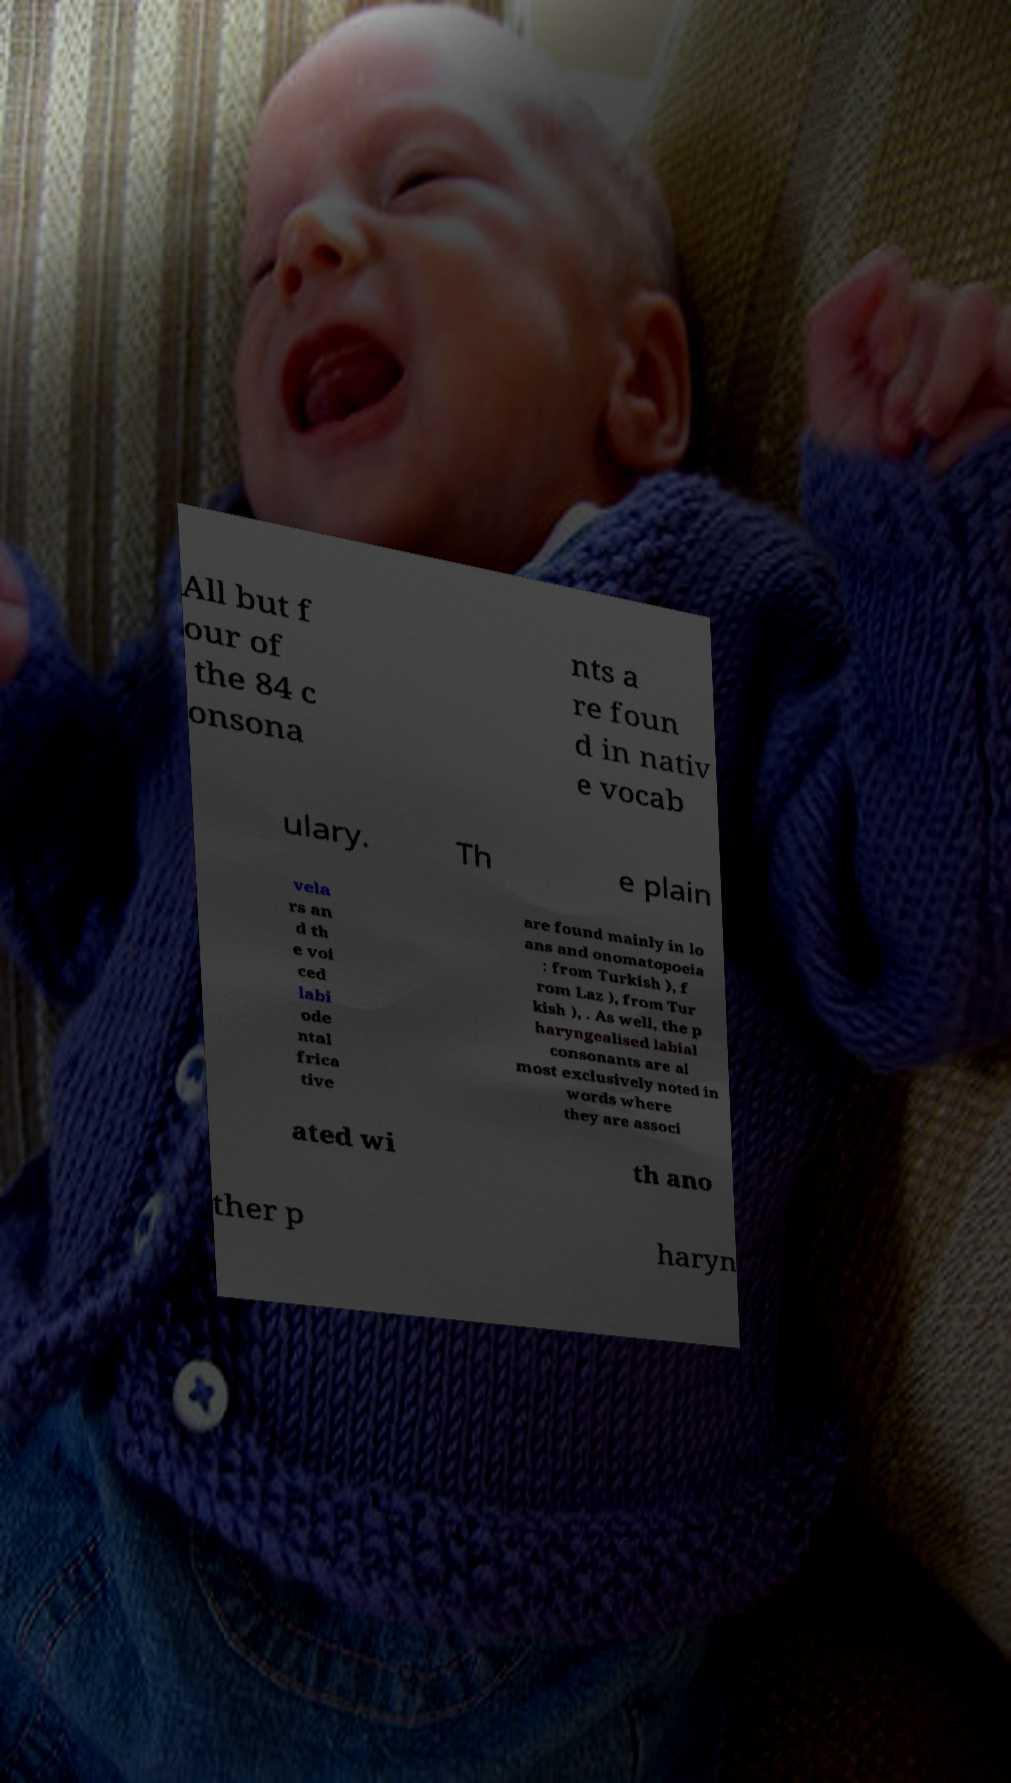There's text embedded in this image that I need extracted. Can you transcribe it verbatim? All but f our of the 84 c onsona nts a re foun d in nativ e vocab ulary. Th e plain vela rs an d th e voi ced labi ode ntal frica tive are found mainly in lo ans and onomatopoeia : from Turkish ), f rom Laz ), from Tur kish ), . As well, the p haryngealised labial consonants are al most exclusively noted in words where they are associ ated wi th ano ther p haryn 